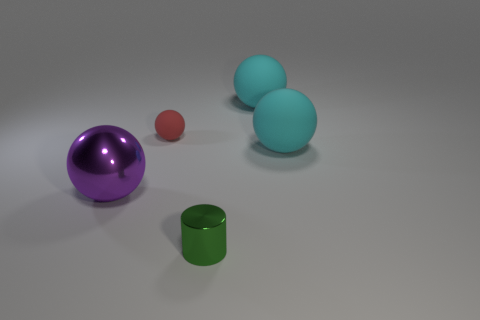Subtract 1 spheres. How many spheres are left? 3 Add 5 tiny red balls. How many objects exist? 10 Subtract all balls. How many objects are left? 1 Add 3 small green metal cylinders. How many small green metal cylinders exist? 4 Subtract 0 cyan cylinders. How many objects are left? 5 Subtract all large yellow metal spheres. Subtract all small things. How many objects are left? 3 Add 1 large cyan matte things. How many large cyan matte things are left? 3 